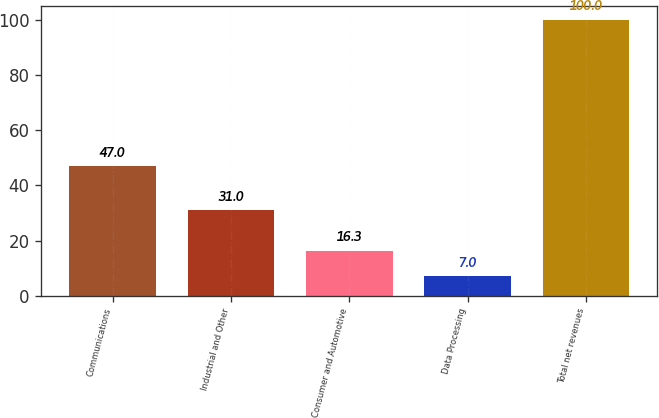<chart> <loc_0><loc_0><loc_500><loc_500><bar_chart><fcel>Communications<fcel>Industrial and Other<fcel>Consumer and Automotive<fcel>Data Processing<fcel>Total net revenues<nl><fcel>47<fcel>31<fcel>16.3<fcel>7<fcel>100<nl></chart> 